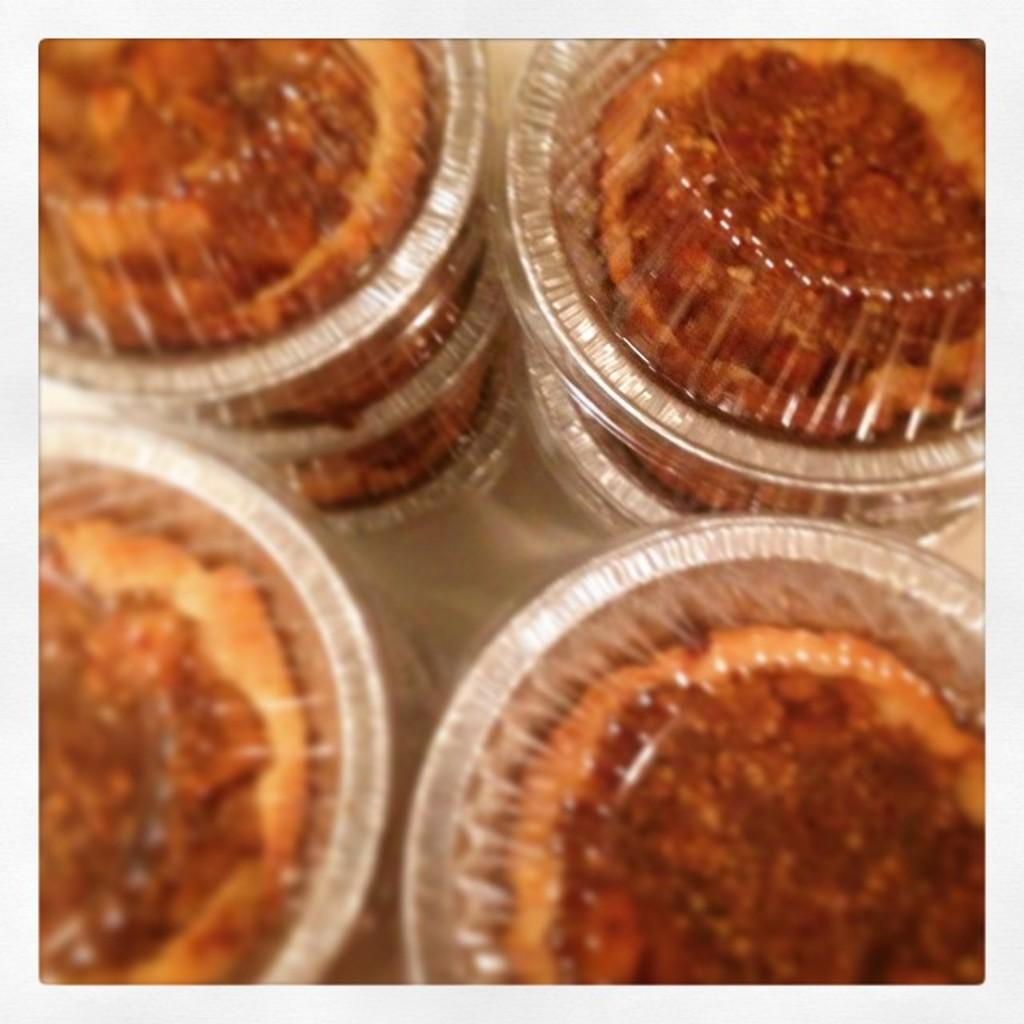What objects are visible in the image? There are cups in the image. What is inside the cups? There is food in the cups. What type of competition is taking place in the image? There is no competition present in the image; it only shows cups with food. 